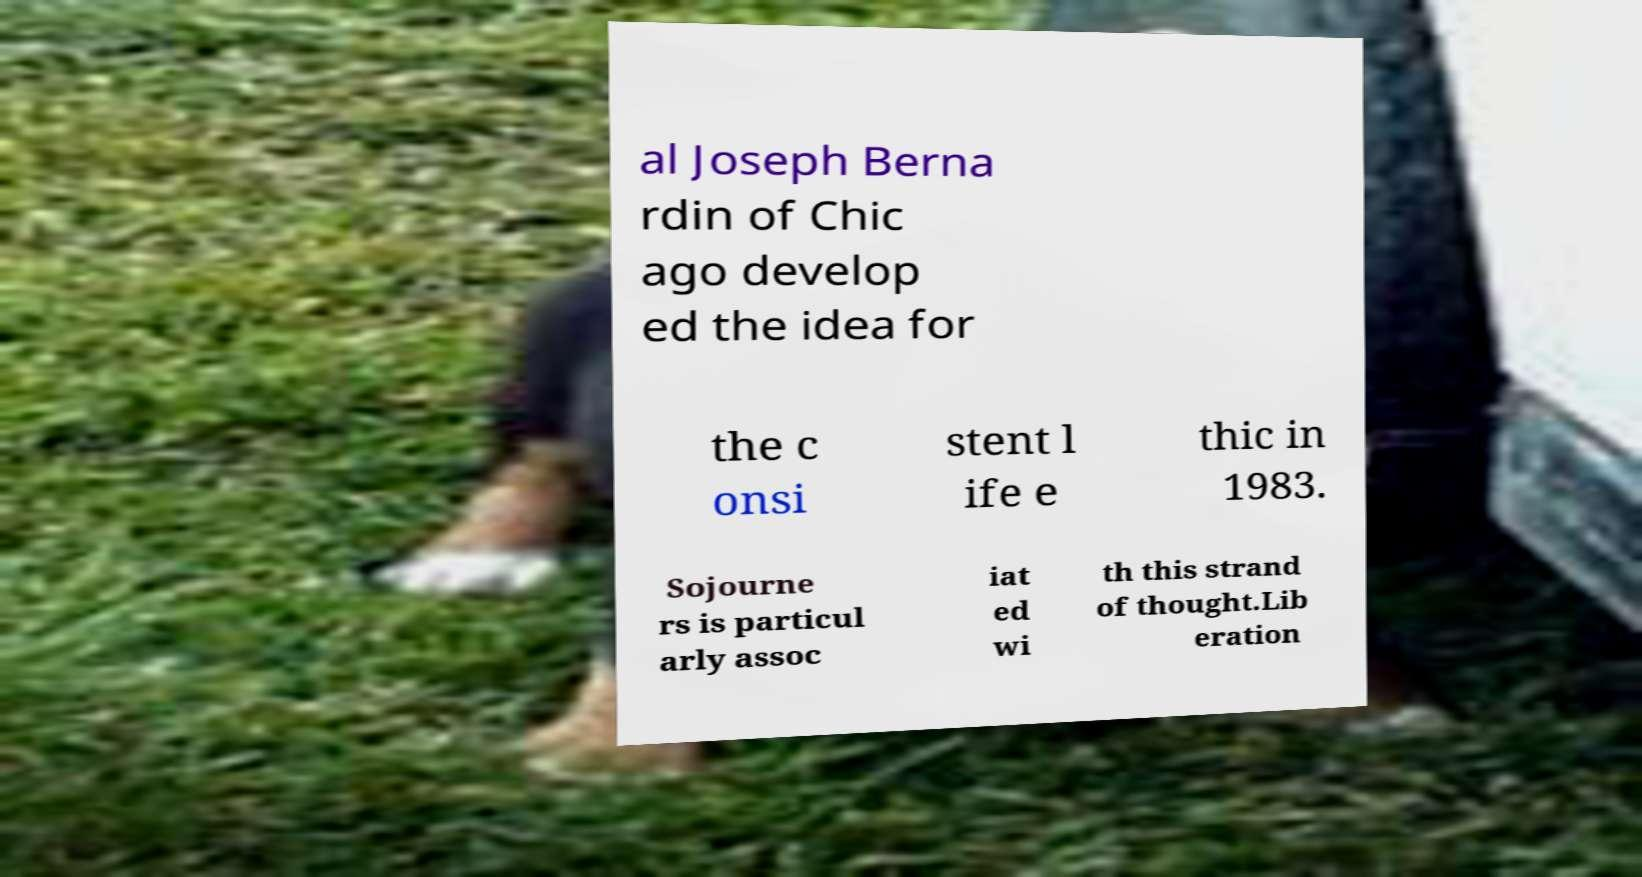What messages or text are displayed in this image? I need them in a readable, typed format. al Joseph Berna rdin of Chic ago develop ed the idea for the c onsi stent l ife e thic in 1983. Sojourne rs is particul arly assoc iat ed wi th this strand of thought.Lib eration 